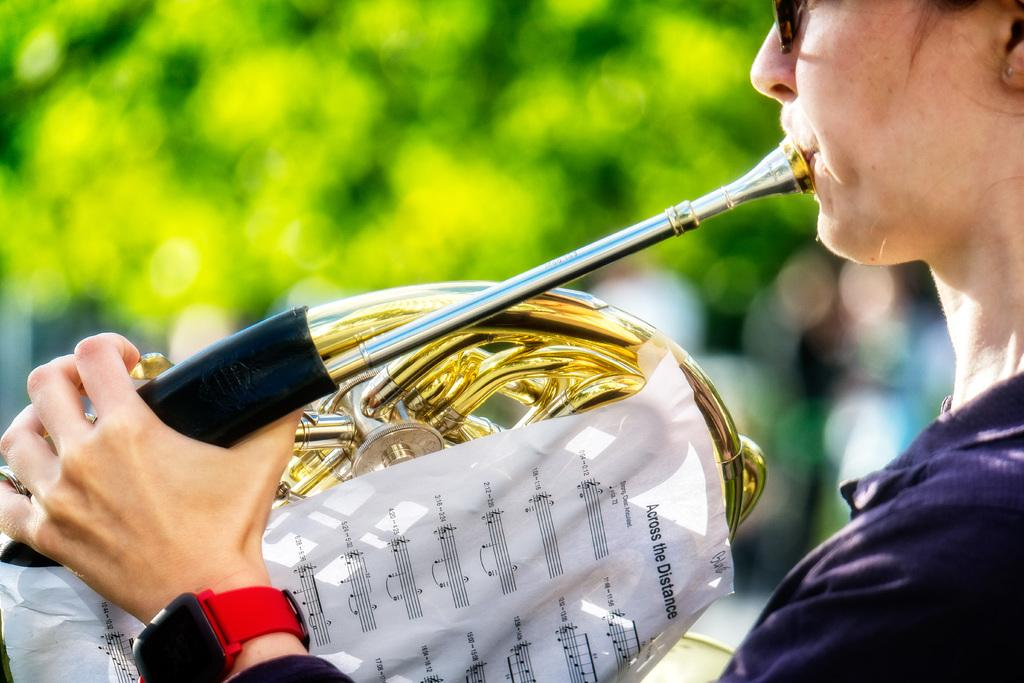<image>
Describe the image concisely. A woman playing a french horn with the song across the distance taped to it. 